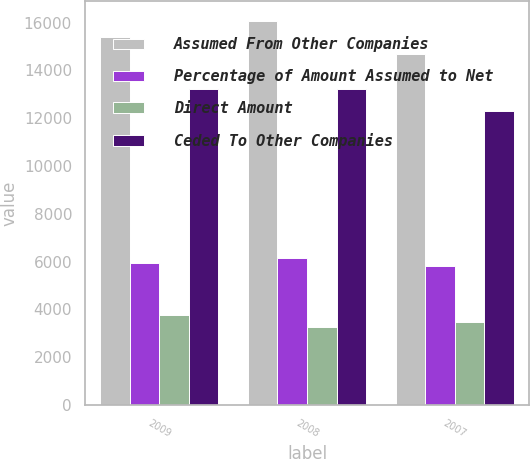Convert chart to OTSL. <chart><loc_0><loc_0><loc_500><loc_500><stacked_bar_chart><ecel><fcel>2009<fcel>2008<fcel>2007<nl><fcel>Assumed From Other Companies<fcel>15415<fcel>16087<fcel>14673<nl><fcel>Percentage of Amount Assumed to Net<fcel>5943<fcel>6144<fcel>5834<nl><fcel>Direct Amount<fcel>3768<fcel>3260<fcel>3458<nl><fcel>Ceded To Other Companies<fcel>13240<fcel>13203<fcel>12297<nl></chart> 